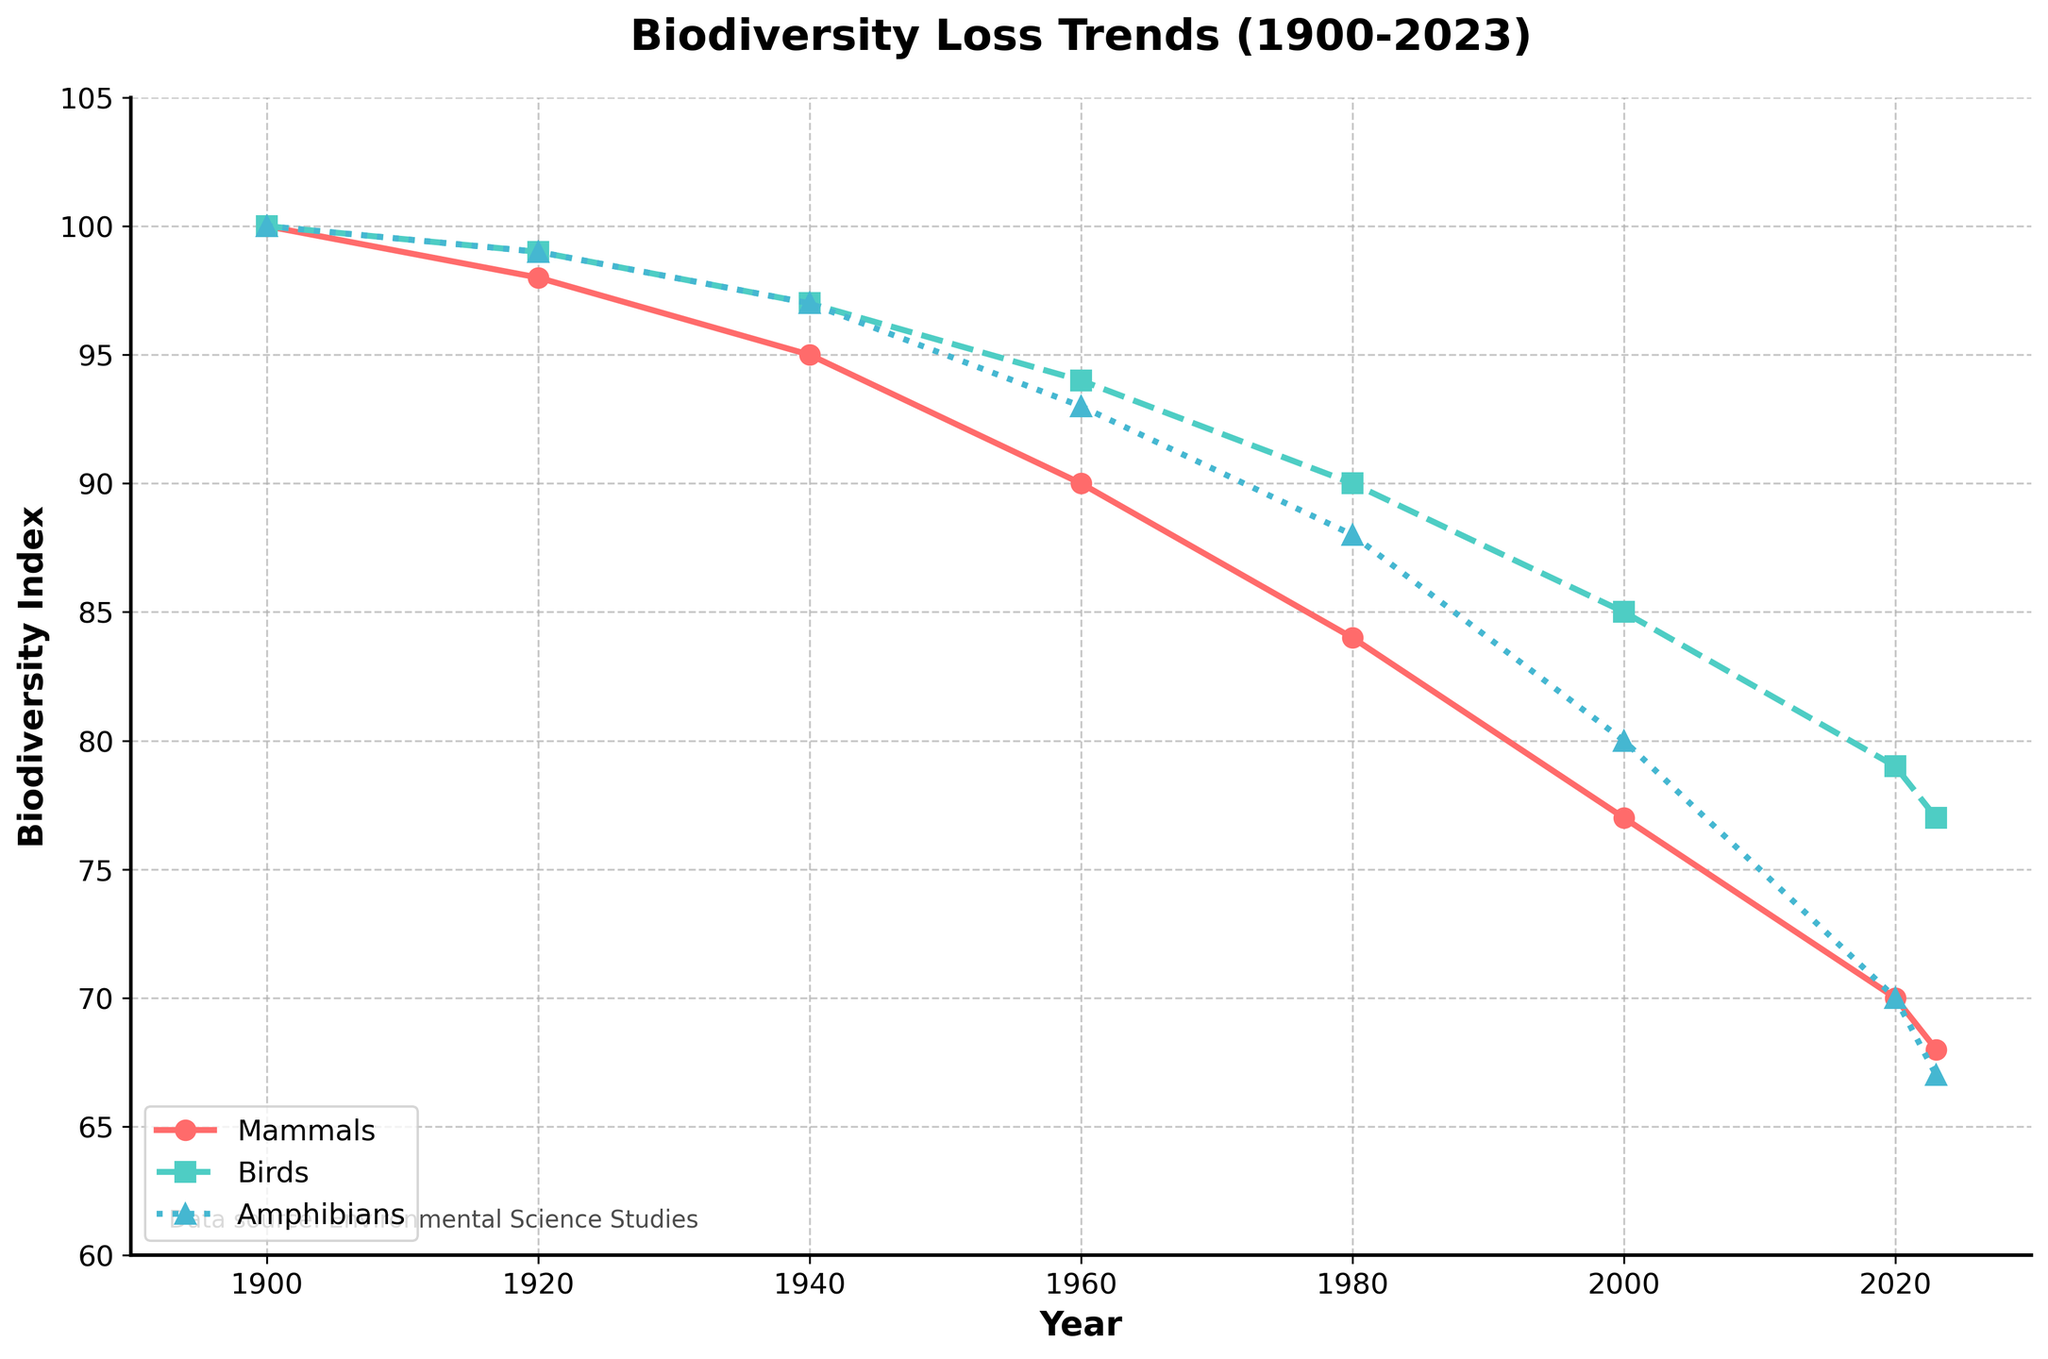Which animal group showed the greatest biodiversity loss from 1900 to 2023? Look at the starting and ending values of each animal group. Mammals started at 100 and decreased to 68, birds started at 100 and decreased to 77, and amphibians started at 100 and decreased to 67. Therefore, amphibians and mammals have the greatest biodiversity loss, but amphibians have a slightly higher loss.
Answer: Amphibians Which animal group showed the least biodiversity loss from 1900 to 2023? Similarly, compare the starting and ending values for each group. Birds went from 100 to 77, representing the smallest loss compared to mammals and amphibians.
Answer: Birds What was the biodiversity index for mammals in the year 1980? Locate the year 1980 on the x-axis and find the corresponding value for the mammals' line (red). The value at 1980 is 84.
Answer: 84 Which year showed the steepest decline in the biodiversity index for amphibians? Find the steepest declining section of the amphibians' line (blue). The steepest decline occurs between 2000 and 2020, where the index decreased from 80 to 70.
Answer: 2000-2020 What is the approximate average biodiversity index for birds over the given years? Sum the index values for birds for the years provided and divide by the number of years: (100 + 99 + 97 + 94 + 90 + 85 + 79 + 77) / 8 = 720 / 8 = 90.
Answer: 90 In which year did mammals first drop below a biodiversity index of 80? Examine the years when the mammals' index falls below 80. The drop first occurs between 1980 and 2000, and the exact year is 2000 where the index reaches 77.
Answer: 2000 By how much did the biodiversity index for birds decrease between 1920 and 2020? Subtract the 2020 value from the 1920 value for birds: 99 - 79 = 20.
Answer: 20 Which animal group's biodiversity index remained above 80 the longest? Look at the years when each group's index stays above 80. Birds stayed above 80 until 2000, while mammals and amphibians fell below 80 earlier.
Answer: Birds How does the biodiversity trend for amphibians compare to mammals between 1960 and 2023? Compare the slopes of the lines for amphibians and mammals from 1960 to 2023. Both decline, but amphibians show a steeper drop from 1960 (93) to 2023 (67) compared to mammals from 1960 (90) to 2023 (68).
Answer: Amphibians declined more steeply What is the difference in the biodiversity index between birds and mammals in 2023? Look at the values for birds and mammals in 2023. Birds are at 77, and mammals are at 68. The difference is 77 - 68 = 9.
Answer: 9 